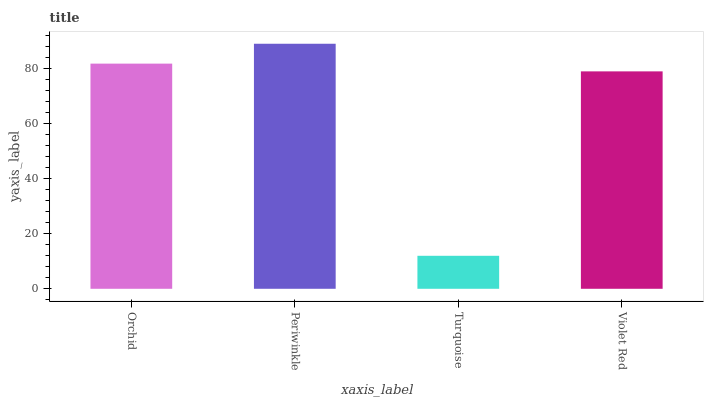Is Turquoise the minimum?
Answer yes or no. Yes. Is Periwinkle the maximum?
Answer yes or no. Yes. Is Periwinkle the minimum?
Answer yes or no. No. Is Turquoise the maximum?
Answer yes or no. No. Is Periwinkle greater than Turquoise?
Answer yes or no. Yes. Is Turquoise less than Periwinkle?
Answer yes or no. Yes. Is Turquoise greater than Periwinkle?
Answer yes or no. No. Is Periwinkle less than Turquoise?
Answer yes or no. No. Is Orchid the high median?
Answer yes or no. Yes. Is Violet Red the low median?
Answer yes or no. Yes. Is Violet Red the high median?
Answer yes or no. No. Is Turquoise the low median?
Answer yes or no. No. 